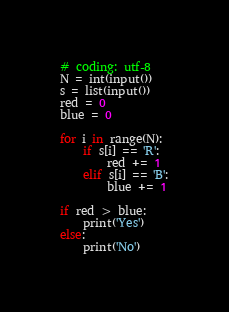Convert code to text. <code><loc_0><loc_0><loc_500><loc_500><_Python_># coding: utf-8
N = int(input())
s = list(input())
red = 0
blue = 0

for i in range(N):
    if s[i] == 'R':
        red += 1
    elif s[i] == 'B':
        blue += 1

if red > blue:
    print('Yes')
else:
    print('No')
</code> 